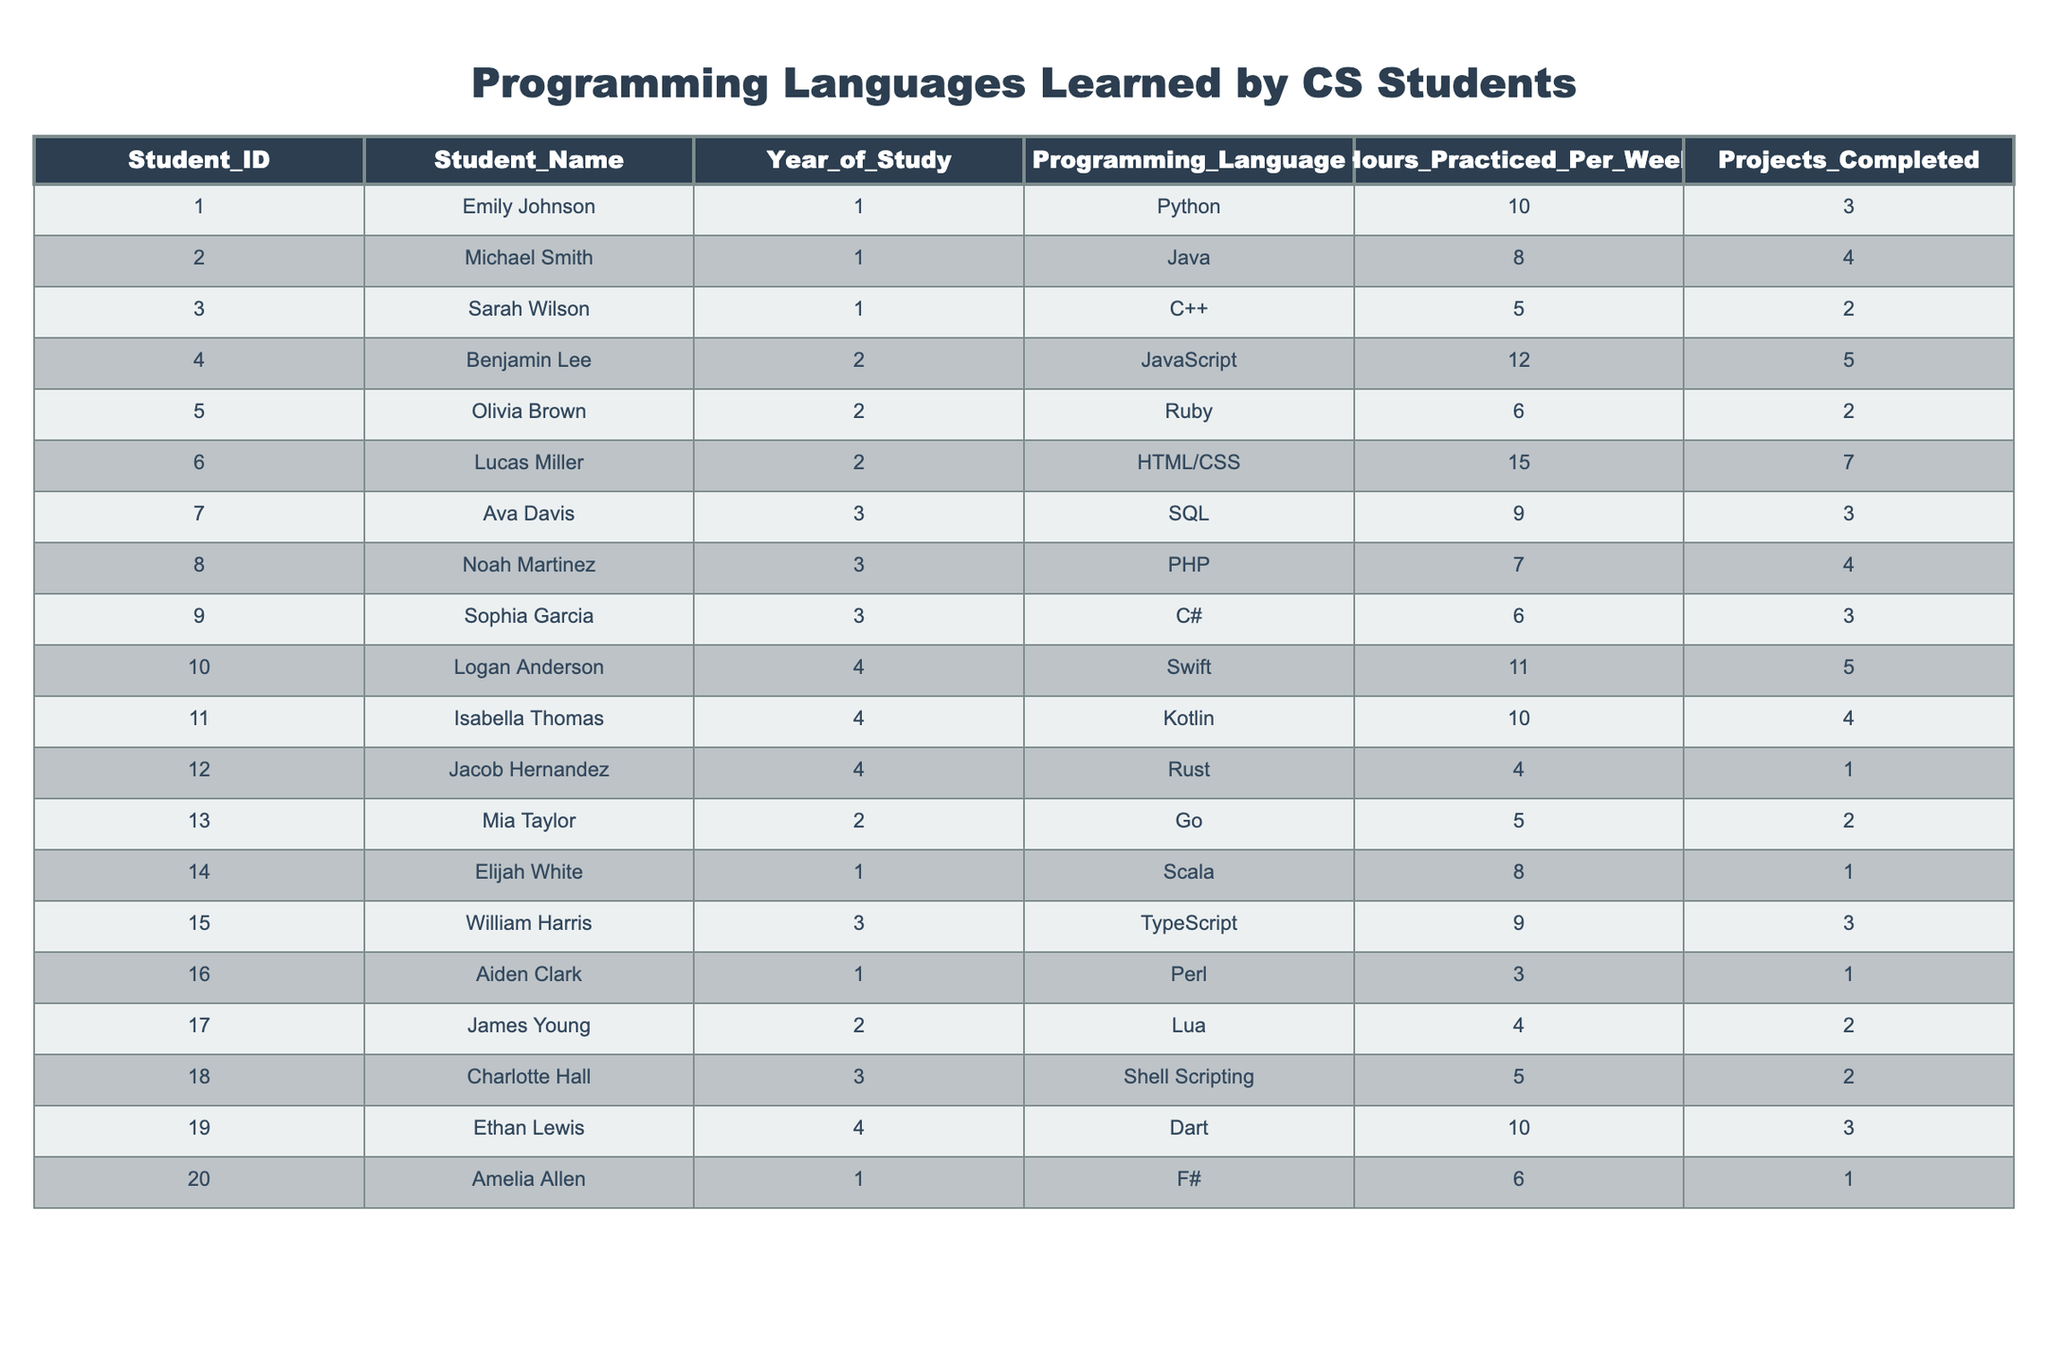What is the most common programming language learned by first-year students? Looking at the table, the programming languages learned by first-year students (Emily, Michael, Sarah, Elijah, and Amelia) are Python, Java, C++, Scala, and F#. F# is the only one with only one student; the others have two or more, making Python and Java the most common as they are learned by two students each.
Answer: Python and Java How many total projects did second-year students complete? The projects completed by the second-year students (Benjamin, Olivia, Lucas, Mia, and James) are 5, 2, 7, 2, and 2, respectively. Adding these values gives 5 + 2 + 7 + 2 + 2 = 18.
Answer: 18 What is the average number of hours practiced per week by all students? To calculate the average, we sum all hours practiced: 10 + 8 + 5 + 12 + 6 + 15 + 9 + 7 + 6 + 11 + 10 + 4 + 5 + 8 + 9 + 3 + 4 + 5 + 10 + 6 = 179. Dividing by the number of students (20) gives 179/20 = 8.95.
Answer: 8.95 Did any student learn more than one programming language? The table shows each student's programming language learned as a single entry, indicating no student is listed with multiple languages. Thus, no student learned more than one programming language according to this data.
Answer: No Which programming language had the highest practice hour among all students? By checking the hours practiced for each language, we find HTML/CSS had the highest at 15 hours per week (Lucas). Therefore, HTML/CSS is the language with the highest practice hours.
Answer: HTML/CSS How many projects were completed by students who practiced at least 10 hours a week? Students practicing at least 10 hours per week are Emily (3), Benjamin (5), Lucas (7), Logan (5), Isabella (4), and Ethan (3). Summing their completed projects gives 3 + 5 + 7 + 5 + 4 + 3 = 27.
Answer: 27 What percentage of students learned a language that starts with the letter J? The languages starting with J are Java (Michael) and JavaScript (Benjamin). With 2 out of 20 students learning these languages, the percentage is (2/20) * 100 = 10%.
Answer: 10% What is the minimum number of projects completed by a student in their final year? The students in their final year are Logan (5), Isabella (4), and Jacob (1). The minimum completed projects among them is 1 (Jacob).
Answer: 1 Which year had the most students learning C-based languages (C++, C#, and Go)? In year 1, there's C++, and in year 2, there's Go. In year 3, there's C#. So, each of the years 1, 2, and 3 has one course each, totaling three C-based languages taught across these years. However, the year with the highest frequency of C-based languages is year 2 and year 3, with one language each.
Answer: Years 2 and 3 Which programming languages did students practice for less than 5 hours per week? The languages practiced for less than 5 hours are Perl (3), Rust (4), and Lua (4). Thus, the languages fitting this criterion are Perl, Rust, and Lua.
Answer: Perl, Rust, and Lua 